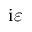<formula> <loc_0><loc_0><loc_500><loc_500>i \varepsilon</formula> 